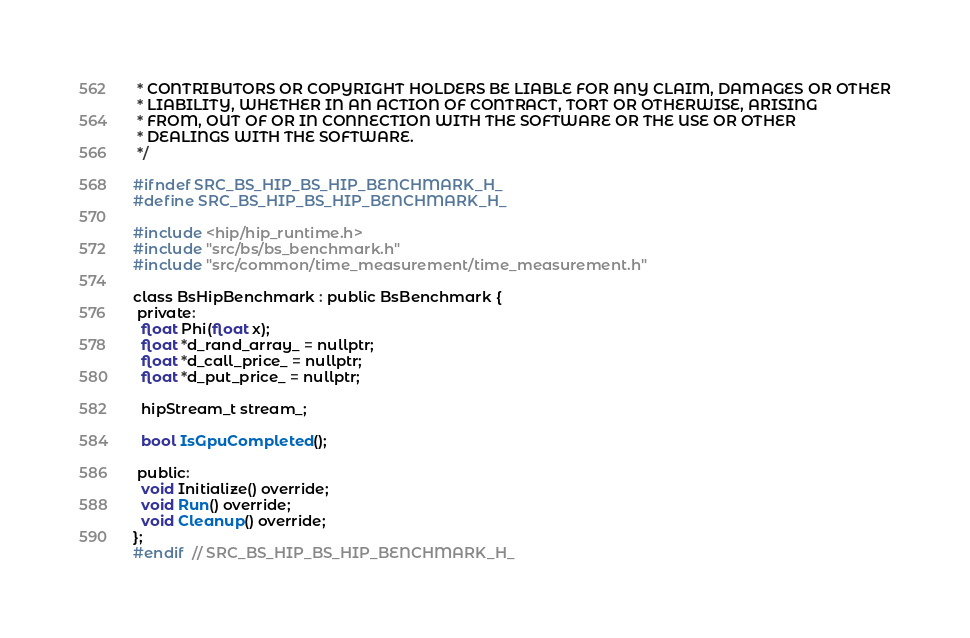Convert code to text. <code><loc_0><loc_0><loc_500><loc_500><_C_> * CONTRIBUTORS OR COPYRIGHT HOLDERS BE LIABLE FOR ANY CLAIM, DAMAGES OR OTHER
 * LIABILITY, WHETHER IN AN ACTION OF CONTRACT, TORT OR OTHERWISE, ARISING
 * FROM, OUT OF OR IN CONNECTION WITH THE SOFTWARE OR THE USE OR OTHER
 * DEALINGS WITH THE SOFTWARE.
 */

#ifndef SRC_BS_HIP_BS_HIP_BENCHMARK_H_
#define SRC_BS_HIP_BS_HIP_BENCHMARK_H_

#include <hip/hip_runtime.h>
#include "src/bs/bs_benchmark.h"
#include "src/common/time_measurement/time_measurement.h"

class BsHipBenchmark : public BsBenchmark {
 private:
  float Phi(float x);
  float *d_rand_array_ = nullptr;
  float *d_call_price_ = nullptr;
  float *d_put_price_ = nullptr;

  hipStream_t stream_;

  bool IsGpuCompleted();

 public:
  void Initialize() override;
  void Run() override;
  void Cleanup() override;
};
#endif  // SRC_BS_HIP_BS_HIP_BENCHMARK_H_
</code> 